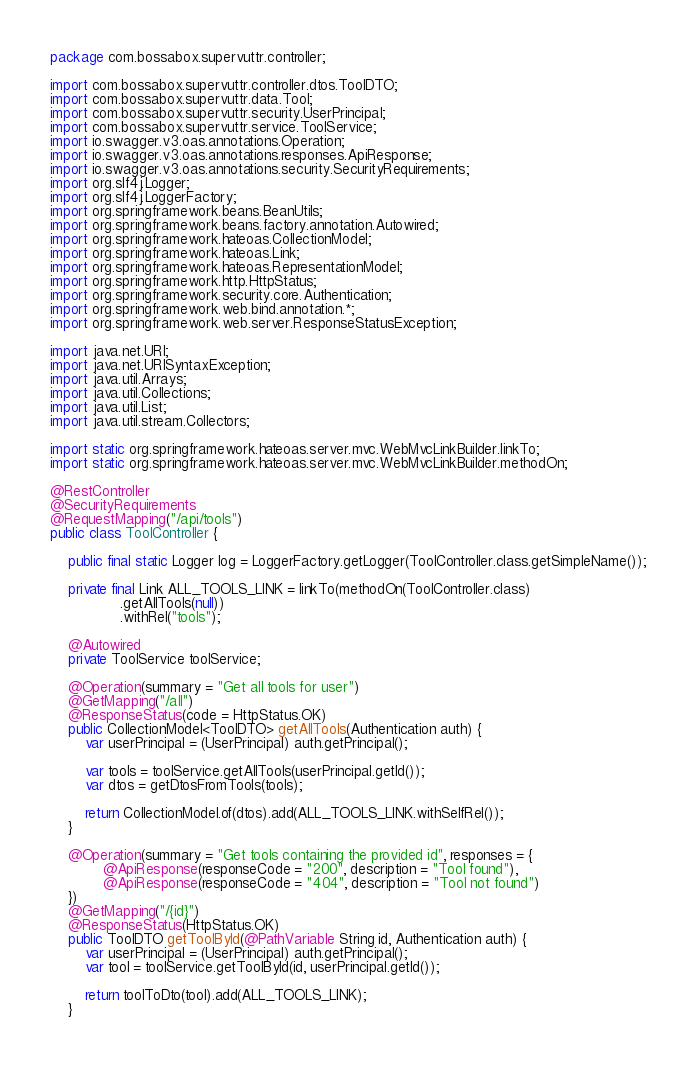Convert code to text. <code><loc_0><loc_0><loc_500><loc_500><_Java_>package com.bossabox.supervuttr.controller;

import com.bossabox.supervuttr.controller.dtos.ToolDTO;
import com.bossabox.supervuttr.data.Tool;
import com.bossabox.supervuttr.security.UserPrincipal;
import com.bossabox.supervuttr.service.ToolService;
import io.swagger.v3.oas.annotations.Operation;
import io.swagger.v3.oas.annotations.responses.ApiResponse;
import io.swagger.v3.oas.annotations.security.SecurityRequirements;
import org.slf4j.Logger;
import org.slf4j.LoggerFactory;
import org.springframework.beans.BeanUtils;
import org.springframework.beans.factory.annotation.Autowired;
import org.springframework.hateoas.CollectionModel;
import org.springframework.hateoas.Link;
import org.springframework.hateoas.RepresentationModel;
import org.springframework.http.HttpStatus;
import org.springframework.security.core.Authentication;
import org.springframework.web.bind.annotation.*;
import org.springframework.web.server.ResponseStatusException;

import java.net.URI;
import java.net.URISyntaxException;
import java.util.Arrays;
import java.util.Collections;
import java.util.List;
import java.util.stream.Collectors;

import static org.springframework.hateoas.server.mvc.WebMvcLinkBuilder.linkTo;
import static org.springframework.hateoas.server.mvc.WebMvcLinkBuilder.methodOn;

@RestController
@SecurityRequirements
@RequestMapping("/api/tools")
public class ToolController {

    public final static Logger log = LoggerFactory.getLogger(ToolController.class.getSimpleName());

    private final Link ALL_TOOLS_LINK = linkTo(methodOn(ToolController.class)
                .getAllTools(null))
                .withRel("tools");

    @Autowired
    private ToolService toolService;

    @Operation(summary = "Get all tools for user")
    @GetMapping("/all")
    @ResponseStatus(code = HttpStatus.OK)
    public CollectionModel<ToolDTO> getAllTools(Authentication auth) {
        var userPrincipal = (UserPrincipal) auth.getPrincipal();

        var tools = toolService.getAllTools(userPrincipal.getId());
        var dtos = getDtosFromTools(tools);

        return CollectionModel.of(dtos).add(ALL_TOOLS_LINK.withSelfRel());
    }

    @Operation(summary = "Get tools containing the provided id", responses = {
            @ApiResponse(responseCode = "200", description = "Tool found"),
            @ApiResponse(responseCode = "404", description = "Tool not found")
    })
    @GetMapping("/{id}")
    @ResponseStatus(HttpStatus.OK)
    public ToolDTO getToolById(@PathVariable String id, Authentication auth) {
        var userPrincipal = (UserPrincipal) auth.getPrincipal();
        var tool = toolService.getToolById(id, userPrincipal.getId());

        return toolToDto(tool).add(ALL_TOOLS_LINK);
    }
</code> 